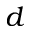<formula> <loc_0><loc_0><loc_500><loc_500>d</formula> 